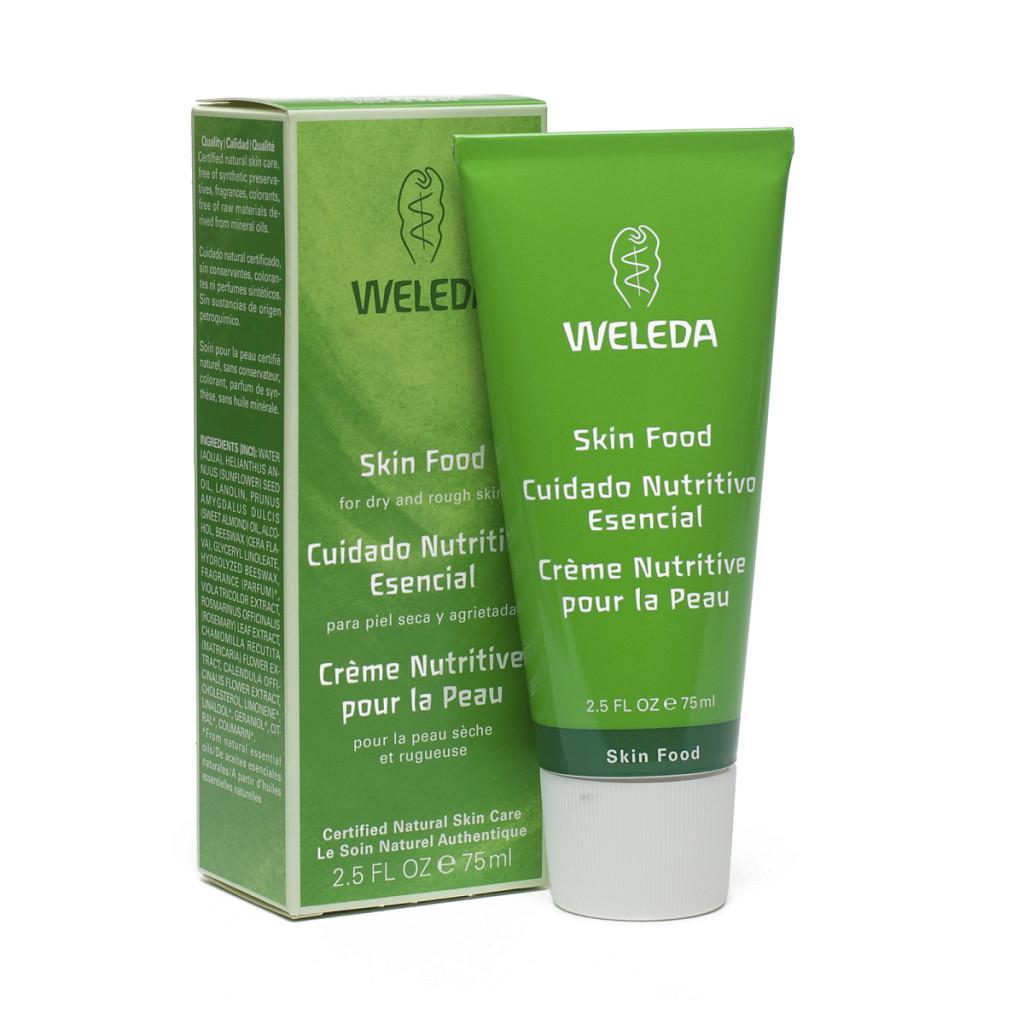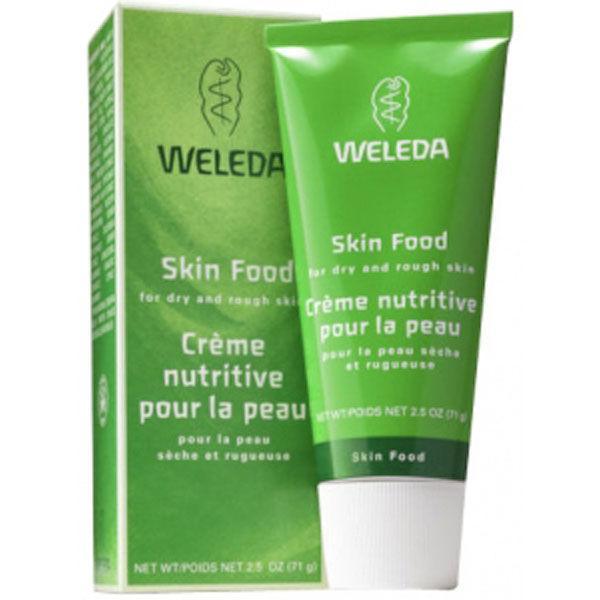The first image is the image on the left, the second image is the image on the right. Considering the images on both sides, is "In at least one image, there is a green tube with a white cap next to a green box packaging" valid? Answer yes or no. Yes. 